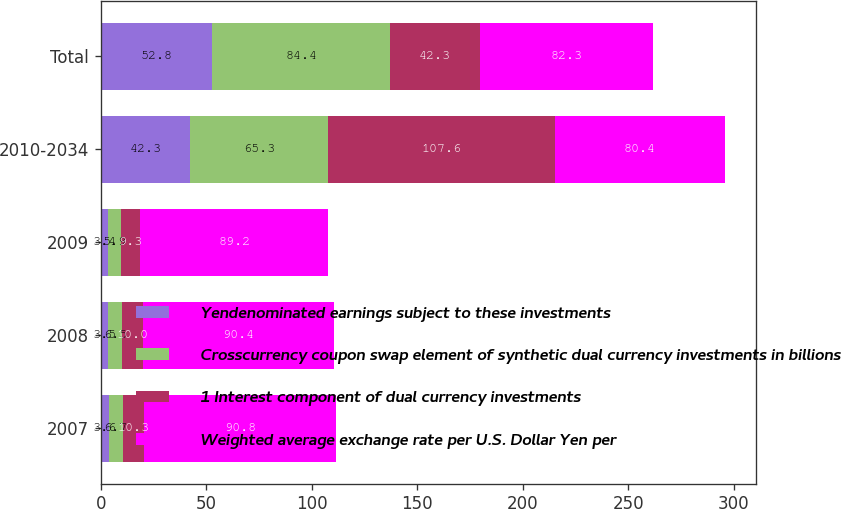Convert chart. <chart><loc_0><loc_0><loc_500><loc_500><stacked_bar_chart><ecel><fcel>2007<fcel>2008<fcel>2009<fcel>2010-2034<fcel>Total<nl><fcel>Yendenominated earnings subject to these investments<fcel>3.6<fcel>3.5<fcel>3.4<fcel>42.3<fcel>52.8<nl><fcel>Crosscurrency coupon swap element of synthetic dual currency investments in billions<fcel>6.7<fcel>6.5<fcel>5.9<fcel>65.3<fcel>84.4<nl><fcel>1 Interest component of dual currency investments<fcel>10.3<fcel>10<fcel>9.3<fcel>107.6<fcel>42.3<nl><fcel>Weighted average exchange rate per U.S. Dollar Yen per<fcel>90.8<fcel>90.4<fcel>89.2<fcel>80.4<fcel>82.3<nl></chart> 